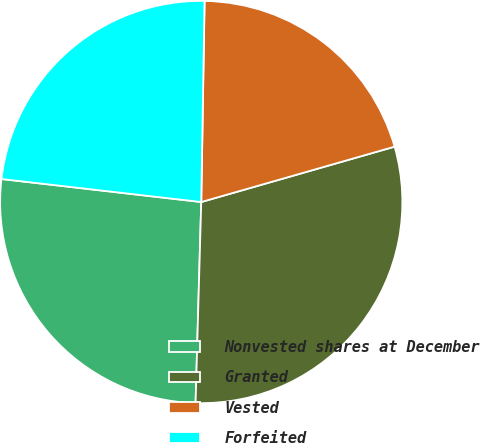Convert chart. <chart><loc_0><loc_0><loc_500><loc_500><pie_chart><fcel>Nonvested shares at December<fcel>Granted<fcel>Vested<fcel>Forfeited<nl><fcel>26.38%<fcel>29.89%<fcel>20.3%<fcel>23.44%<nl></chart> 